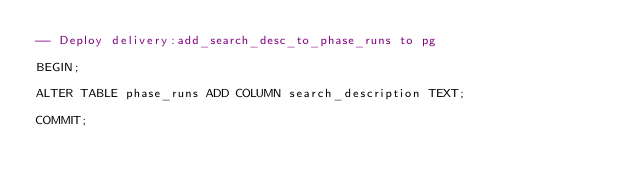Convert code to text. <code><loc_0><loc_0><loc_500><loc_500><_SQL_>-- Deploy delivery:add_search_desc_to_phase_runs to pg

BEGIN;

ALTER TABLE phase_runs ADD COLUMN search_description TEXT;

COMMIT;
</code> 